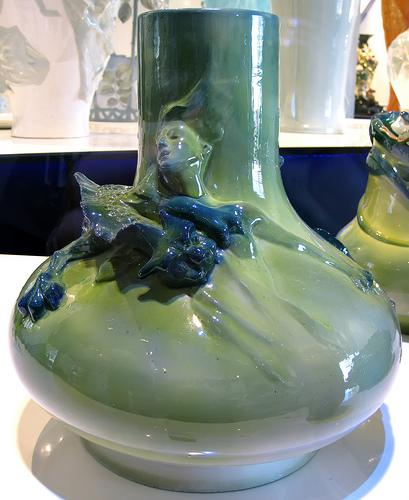Describe the appearance of the woman in the vase relief. The woman in the vase relief has long hair, her eyes are closed, her arm is stretched out, and she seems to be part of an underwater scene. Talk about the positioning and details of the mermaid relief on the vase. The mermaid relief is positioned in the center of the vase, with her face and long hair taking prominence, surrounded by fish and sea creatures. Describe the colors and design of the vase in the image. The vase has a mix of green, blue, and white colors with a unique design featuring a mermaid or woman, fish, and various sea creatures. Describe the setting and environment where the vase is placed in the image. The vase is sitting on a white table with a blue table skirt, surrounded by other vases and sculptures, and blue curtains in the background. Explain the main visual aspects of the image involving the woman on the vase. The image features a shiny green and blue vase with a relief of a woman or mermaid, her eyes closed and arm stretched out, and surrounded by sea life designs. Discuss the colors, patterns, and images you can see on the vase in the image. The vase features green, blue, and white colors with an intricate pattern including a woman or mermaid, fish, sea creatures, and darker green designs. What type of artwork is depicted on the vase in the image? The vase in the image has an intricate relief sculpture of a woman or mermaid with long hair, surrounded by fish and sea creatures. Mention the most prominent feature of the main object in the image. A woman or mermaid relief is the most noticeable feature on the shiny green and blue vase in the image. Provide a brief description of the primary object in the image. A tall green and blue vase features a relief of a woman, possibly a mermaid, surrounded by intricate designs including fish and other sea creatures. Explain the primary object's position in relation to the other objects in the image. The large green and blue vase with the woman relief is placed on a white table, with other antique vases and sculptures nearby, including a yellow vase behind it. 